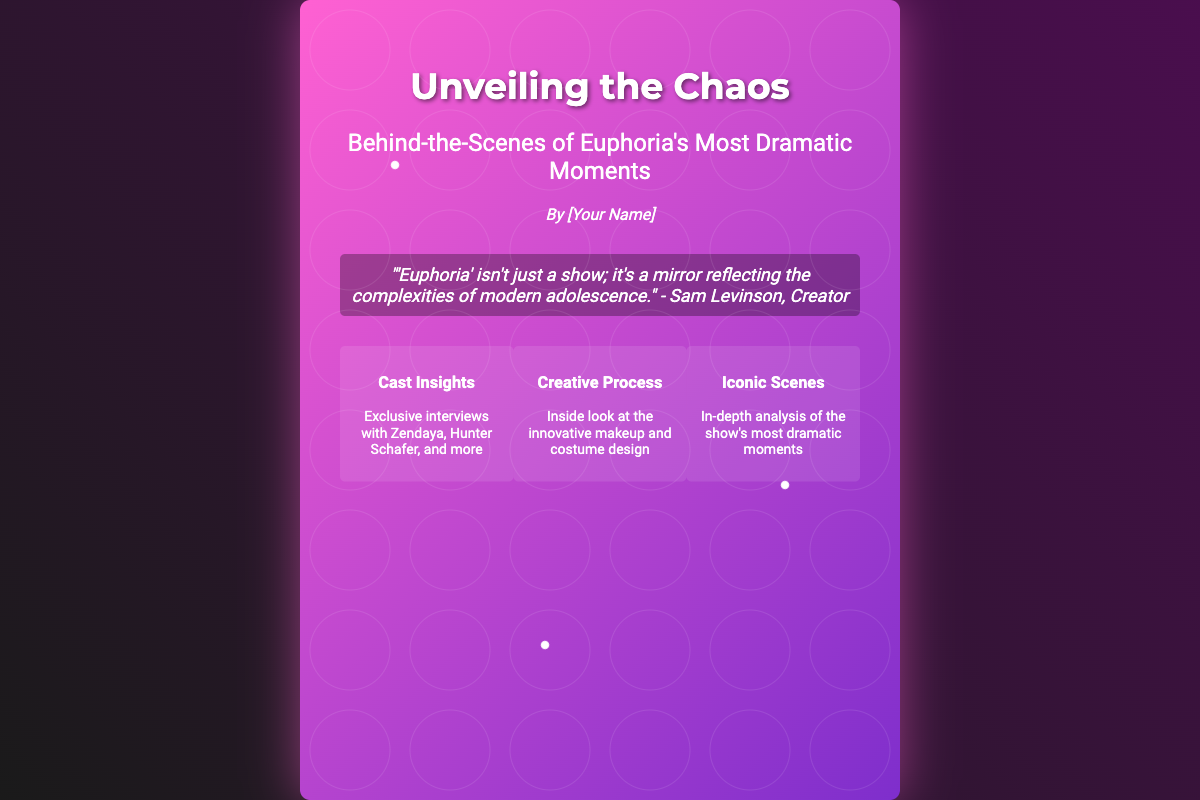What is the title of the book? The title of the book is prominently displayed in the document, which is "Unveiling the Chaos: Behind-the-Scenes of Euphoria's Most Dramatic Moments."
Answer: Unveiling the Chaos: Behind-the-Scenes of Euphoria's Most Dramatic Moments Who is the author of the book? The author is indicated below the title, but it is a placeholder, represented as "[Your Name]."
Answer: [Your Name] What is the main theme of the quote? The quote reflects on the nature of the show "Euphoria," discussing its representation of modern adolescence.
Answer: Modern adolescence Which cast members are mentioned in the exclusive interviews? The features section lists specific cast members who are interviewed, including Zendaya and Hunter Schafer.
Answer: Zendaya, Hunter Schafer How many key features are highlighted in the cover? The features section outlines distinct categories showcasing elements of the show, which are three in total.
Answer: Three What type of content does the book include about the show's makeup? The document specifies that there is an inside look at the innovative makeup design as part of the book's features.
Answer: Innovative makeup design What does the feature section contain? The feature section of the document details various insights, including cast insights, creative process, and iconic scenes.
Answer: Cast insights, creative process, iconic scenes What style is used for the author's name? The author's name is stylized in italic to provide emphasis in the document layout.
Answer: Italic What does the background gradient of the book cover represent? The vibrant gradients and colors used in the background aim to reflect the intensity and drama of "Euphoria."
Answer: Intensity and drama 